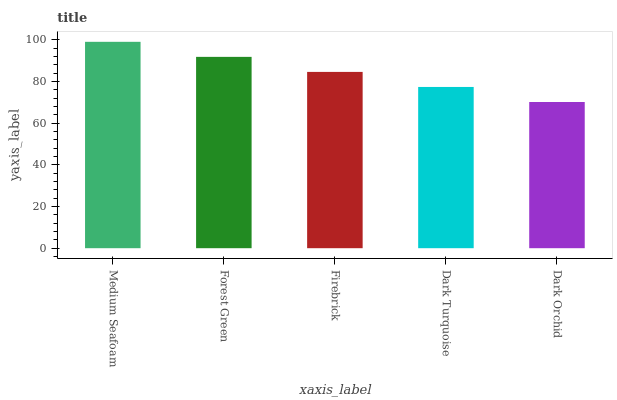Is Dark Orchid the minimum?
Answer yes or no. Yes. Is Medium Seafoam the maximum?
Answer yes or no. Yes. Is Forest Green the minimum?
Answer yes or no. No. Is Forest Green the maximum?
Answer yes or no. No. Is Medium Seafoam greater than Forest Green?
Answer yes or no. Yes. Is Forest Green less than Medium Seafoam?
Answer yes or no. Yes. Is Forest Green greater than Medium Seafoam?
Answer yes or no. No. Is Medium Seafoam less than Forest Green?
Answer yes or no. No. Is Firebrick the high median?
Answer yes or no. Yes. Is Firebrick the low median?
Answer yes or no. Yes. Is Dark Turquoise the high median?
Answer yes or no. No. Is Dark Turquoise the low median?
Answer yes or no. No. 